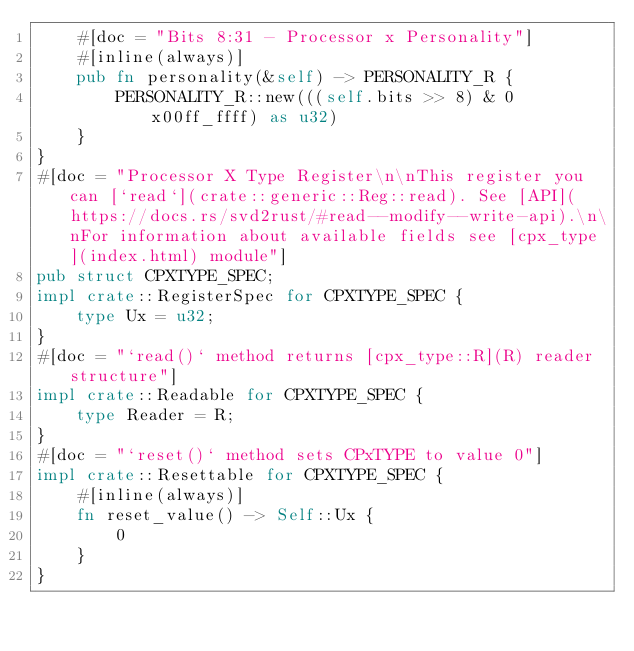Convert code to text. <code><loc_0><loc_0><loc_500><loc_500><_Rust_>    #[doc = "Bits 8:31 - Processor x Personality"]
    #[inline(always)]
    pub fn personality(&self) -> PERSONALITY_R {
        PERSONALITY_R::new(((self.bits >> 8) & 0x00ff_ffff) as u32)
    }
}
#[doc = "Processor X Type Register\n\nThis register you can [`read`](crate::generic::Reg::read). See [API](https://docs.rs/svd2rust/#read--modify--write-api).\n\nFor information about available fields see [cpx_type](index.html) module"]
pub struct CPXTYPE_SPEC;
impl crate::RegisterSpec for CPXTYPE_SPEC {
    type Ux = u32;
}
#[doc = "`read()` method returns [cpx_type::R](R) reader structure"]
impl crate::Readable for CPXTYPE_SPEC {
    type Reader = R;
}
#[doc = "`reset()` method sets CPxTYPE to value 0"]
impl crate::Resettable for CPXTYPE_SPEC {
    #[inline(always)]
    fn reset_value() -> Self::Ux {
        0
    }
}
</code> 